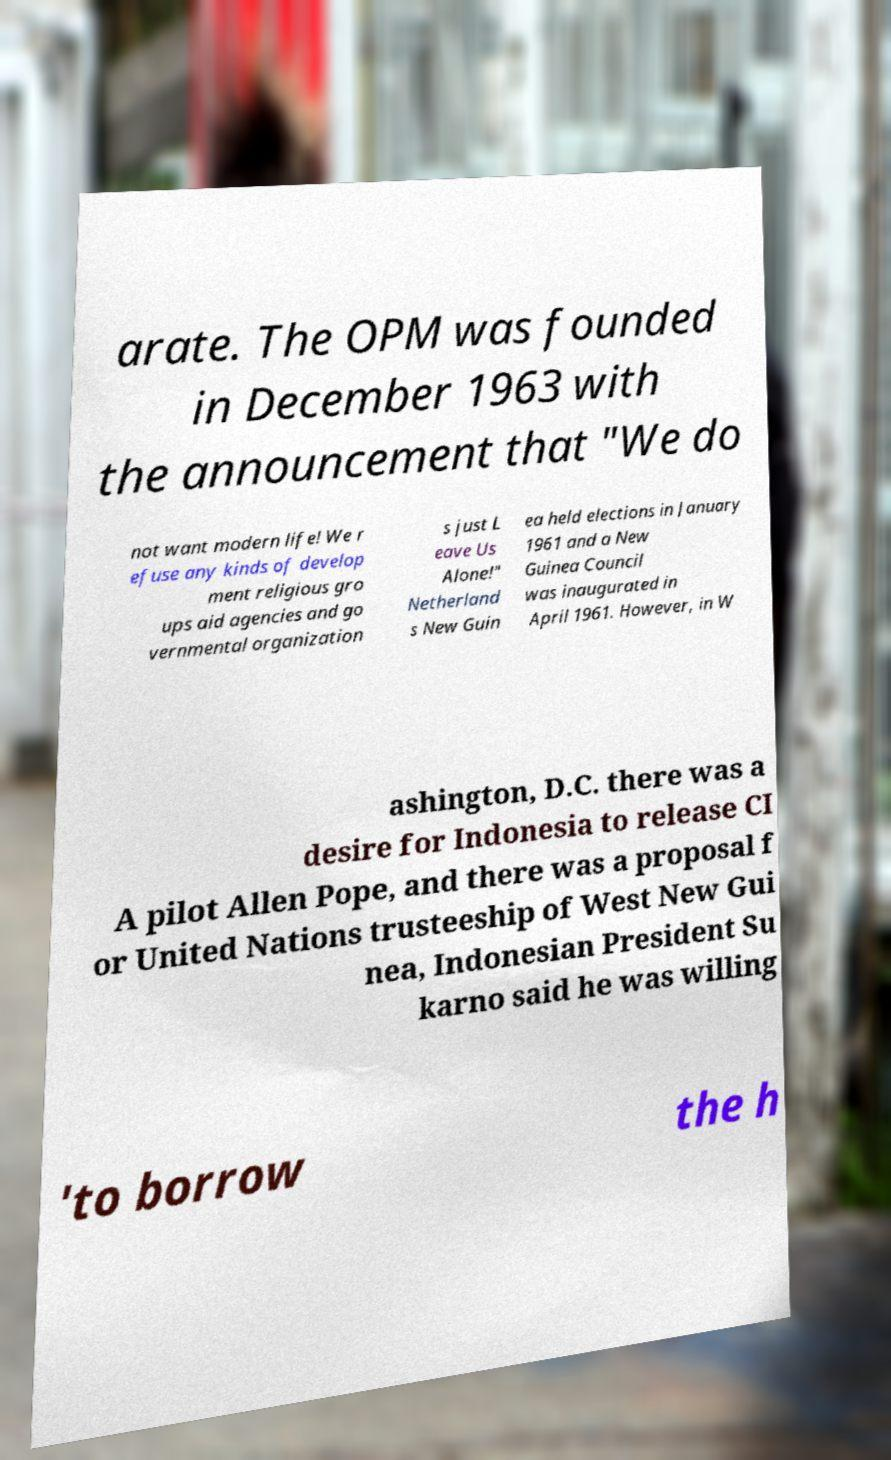Could you assist in decoding the text presented in this image and type it out clearly? arate. The OPM was founded in December 1963 with the announcement that "We do not want modern life! We r efuse any kinds of develop ment religious gro ups aid agencies and go vernmental organization s just L eave Us Alone!" Netherland s New Guin ea held elections in January 1961 and a New Guinea Council was inaugurated in April 1961. However, in W ashington, D.C. there was a desire for Indonesia to release CI A pilot Allen Pope, and there was a proposal f or United Nations trusteeship of West New Gui nea, Indonesian President Su karno said he was willing 'to borrow the h 